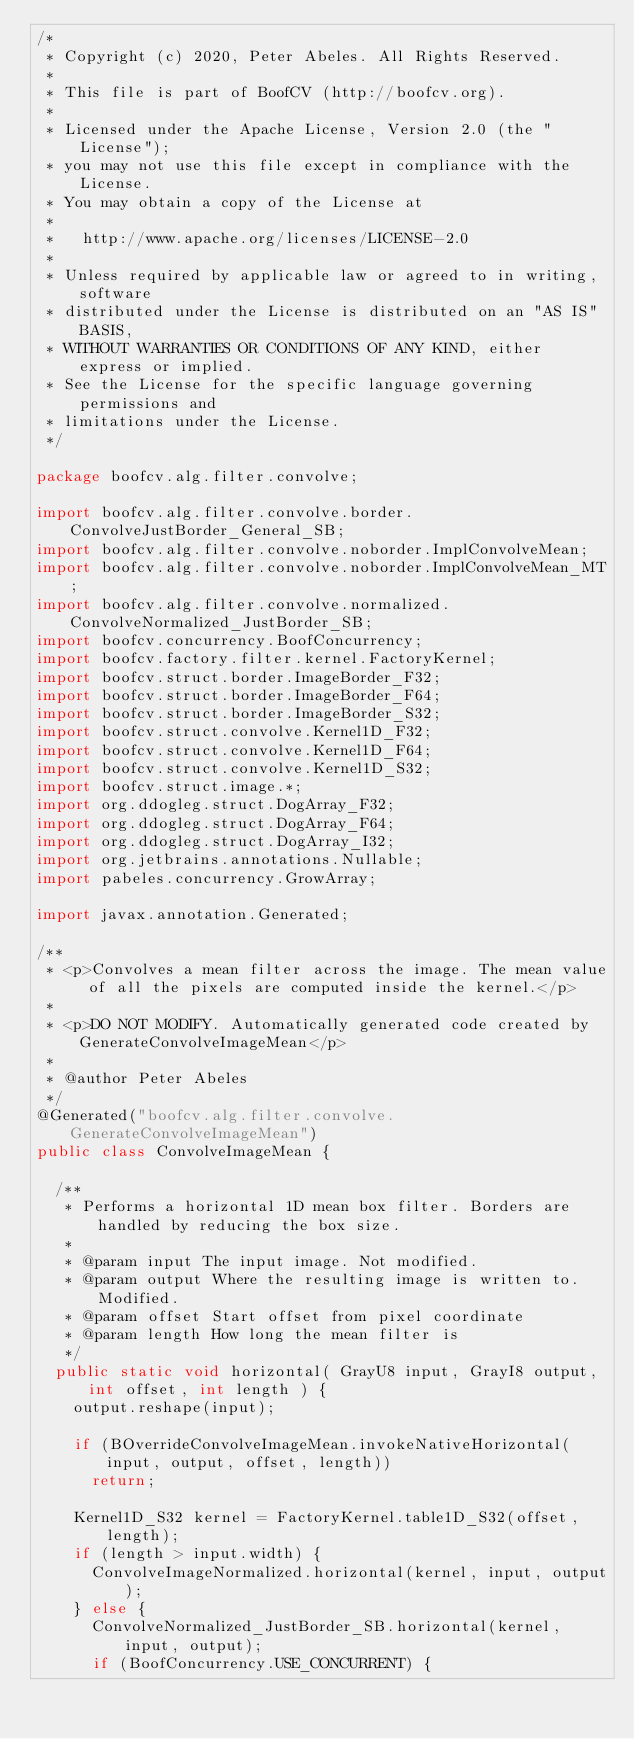<code> <loc_0><loc_0><loc_500><loc_500><_Java_>/*
 * Copyright (c) 2020, Peter Abeles. All Rights Reserved.
 *
 * This file is part of BoofCV (http://boofcv.org).
 *
 * Licensed under the Apache License, Version 2.0 (the "License");
 * you may not use this file except in compliance with the License.
 * You may obtain a copy of the License at
 *
 *   http://www.apache.org/licenses/LICENSE-2.0
 *
 * Unless required by applicable law or agreed to in writing, software
 * distributed under the License is distributed on an "AS IS" BASIS,
 * WITHOUT WARRANTIES OR CONDITIONS OF ANY KIND, either express or implied.
 * See the License for the specific language governing permissions and
 * limitations under the License.
 */

package boofcv.alg.filter.convolve;

import boofcv.alg.filter.convolve.border.ConvolveJustBorder_General_SB;
import boofcv.alg.filter.convolve.noborder.ImplConvolveMean;
import boofcv.alg.filter.convolve.noborder.ImplConvolveMean_MT;
import boofcv.alg.filter.convolve.normalized.ConvolveNormalized_JustBorder_SB;
import boofcv.concurrency.BoofConcurrency;
import boofcv.factory.filter.kernel.FactoryKernel;
import boofcv.struct.border.ImageBorder_F32;
import boofcv.struct.border.ImageBorder_F64;
import boofcv.struct.border.ImageBorder_S32;
import boofcv.struct.convolve.Kernel1D_F32;
import boofcv.struct.convolve.Kernel1D_F64;
import boofcv.struct.convolve.Kernel1D_S32;
import boofcv.struct.image.*;
import org.ddogleg.struct.DogArray_F32;
import org.ddogleg.struct.DogArray_F64;
import org.ddogleg.struct.DogArray_I32;
import org.jetbrains.annotations.Nullable;
import pabeles.concurrency.GrowArray;

import javax.annotation.Generated;

/**
 * <p>Convolves a mean filter across the image. The mean value of all the pixels are computed inside the kernel.</p>
 *
 * <p>DO NOT MODIFY. Automatically generated code created by GenerateConvolveImageMean</p>
 *
 * @author Peter Abeles
 */
@Generated("boofcv.alg.filter.convolve.GenerateConvolveImageMean")
public class ConvolveImageMean {

	/**
	 * Performs a horizontal 1D mean box filter. Borders are handled by reducing the box size.
	 *
	 * @param input The input image. Not modified.
	 * @param output Where the resulting image is written to. Modified.
	 * @param offset Start offset from pixel coordinate
	 * @param length How long the mean filter is
	 */
	public static void horizontal( GrayU8 input, GrayI8 output, int offset, int length ) {
		output.reshape(input);

		if (BOverrideConvolveImageMean.invokeNativeHorizontal(input, output, offset, length))
			return;

		Kernel1D_S32 kernel = FactoryKernel.table1D_S32(offset, length);
		if (length > input.width) {
			ConvolveImageNormalized.horizontal(kernel, input, output);
		} else {
			ConvolveNormalized_JustBorder_SB.horizontal(kernel, input, output);
			if (BoofConcurrency.USE_CONCURRENT) {</code> 